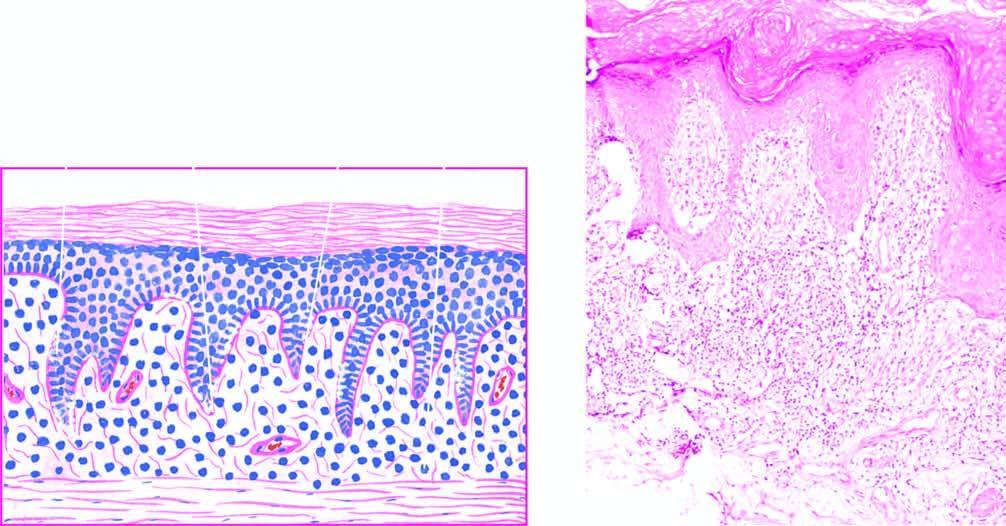s onsumption of tobacco in india hyperkeratosis, focal hypergranulosis and irregular acanthosis with elongated saw-toothed rete ridges?
Answer the question using a single word or phrase. No 